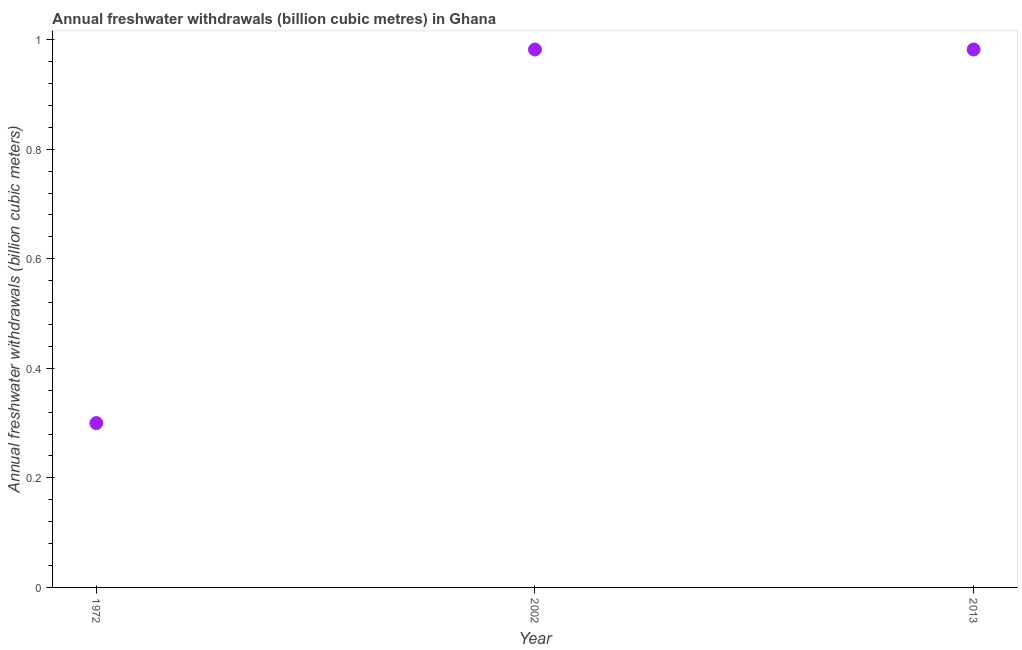What is the annual freshwater withdrawals in 2002?
Offer a very short reply. 0.98. Across all years, what is the maximum annual freshwater withdrawals?
Your answer should be very brief. 0.98. Across all years, what is the minimum annual freshwater withdrawals?
Provide a succinct answer. 0.3. What is the sum of the annual freshwater withdrawals?
Your response must be concise. 2.26. What is the difference between the annual freshwater withdrawals in 1972 and 2013?
Ensure brevity in your answer.  -0.68. What is the average annual freshwater withdrawals per year?
Offer a terse response. 0.75. What is the median annual freshwater withdrawals?
Your answer should be compact. 0.98. In how many years, is the annual freshwater withdrawals greater than 0.44 billion cubic meters?
Provide a short and direct response. 2. What is the ratio of the annual freshwater withdrawals in 1972 to that in 2002?
Keep it short and to the point. 0.31. Is the sum of the annual freshwater withdrawals in 2002 and 2013 greater than the maximum annual freshwater withdrawals across all years?
Offer a very short reply. Yes. What is the difference between the highest and the lowest annual freshwater withdrawals?
Ensure brevity in your answer.  0.68. In how many years, is the annual freshwater withdrawals greater than the average annual freshwater withdrawals taken over all years?
Offer a very short reply. 2. Are the values on the major ticks of Y-axis written in scientific E-notation?
Make the answer very short. No. What is the title of the graph?
Provide a succinct answer. Annual freshwater withdrawals (billion cubic metres) in Ghana. What is the label or title of the X-axis?
Make the answer very short. Year. What is the label or title of the Y-axis?
Provide a succinct answer. Annual freshwater withdrawals (billion cubic meters). What is the Annual freshwater withdrawals (billion cubic meters) in 1972?
Ensure brevity in your answer.  0.3. What is the Annual freshwater withdrawals (billion cubic meters) in 2002?
Offer a terse response. 0.98. What is the Annual freshwater withdrawals (billion cubic meters) in 2013?
Offer a terse response. 0.98. What is the difference between the Annual freshwater withdrawals (billion cubic meters) in 1972 and 2002?
Offer a terse response. -0.68. What is the difference between the Annual freshwater withdrawals (billion cubic meters) in 1972 and 2013?
Offer a very short reply. -0.68. What is the difference between the Annual freshwater withdrawals (billion cubic meters) in 2002 and 2013?
Your answer should be very brief. 0. What is the ratio of the Annual freshwater withdrawals (billion cubic meters) in 1972 to that in 2002?
Your response must be concise. 0.3. What is the ratio of the Annual freshwater withdrawals (billion cubic meters) in 1972 to that in 2013?
Keep it short and to the point. 0.3. 